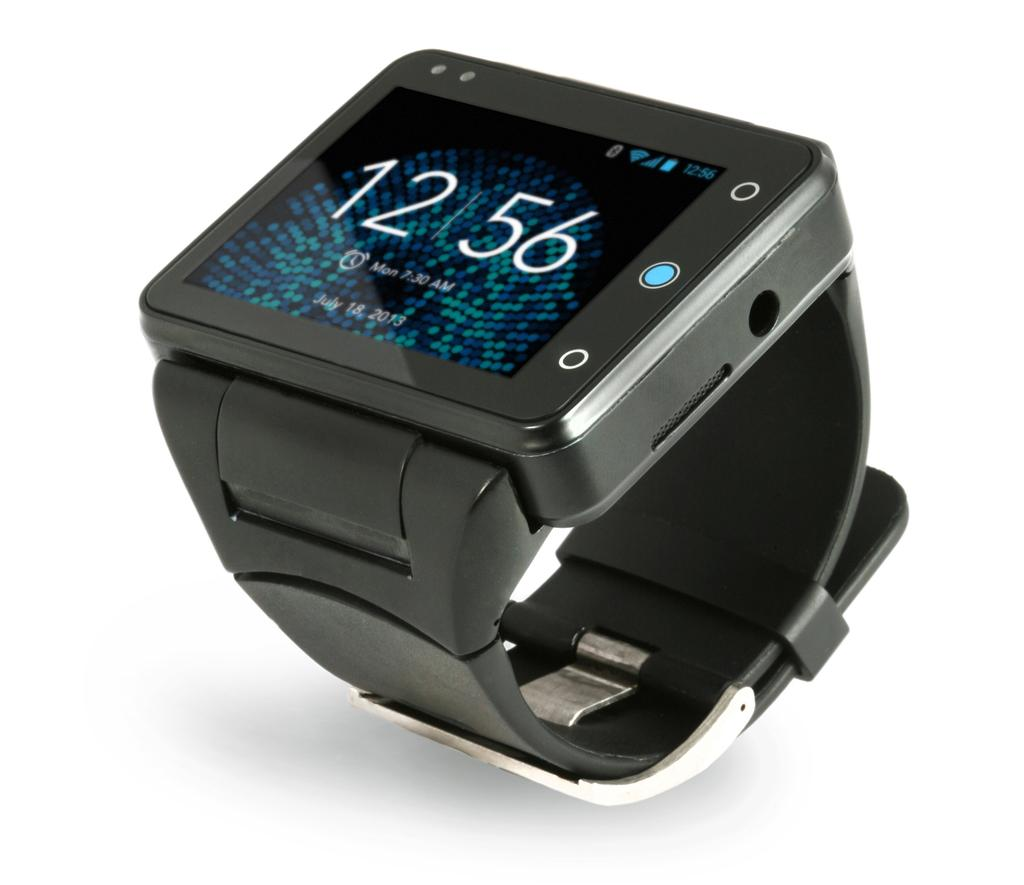Provide a one-sentence caption for the provided image. A digital watch screen displays the time of 12:56. 